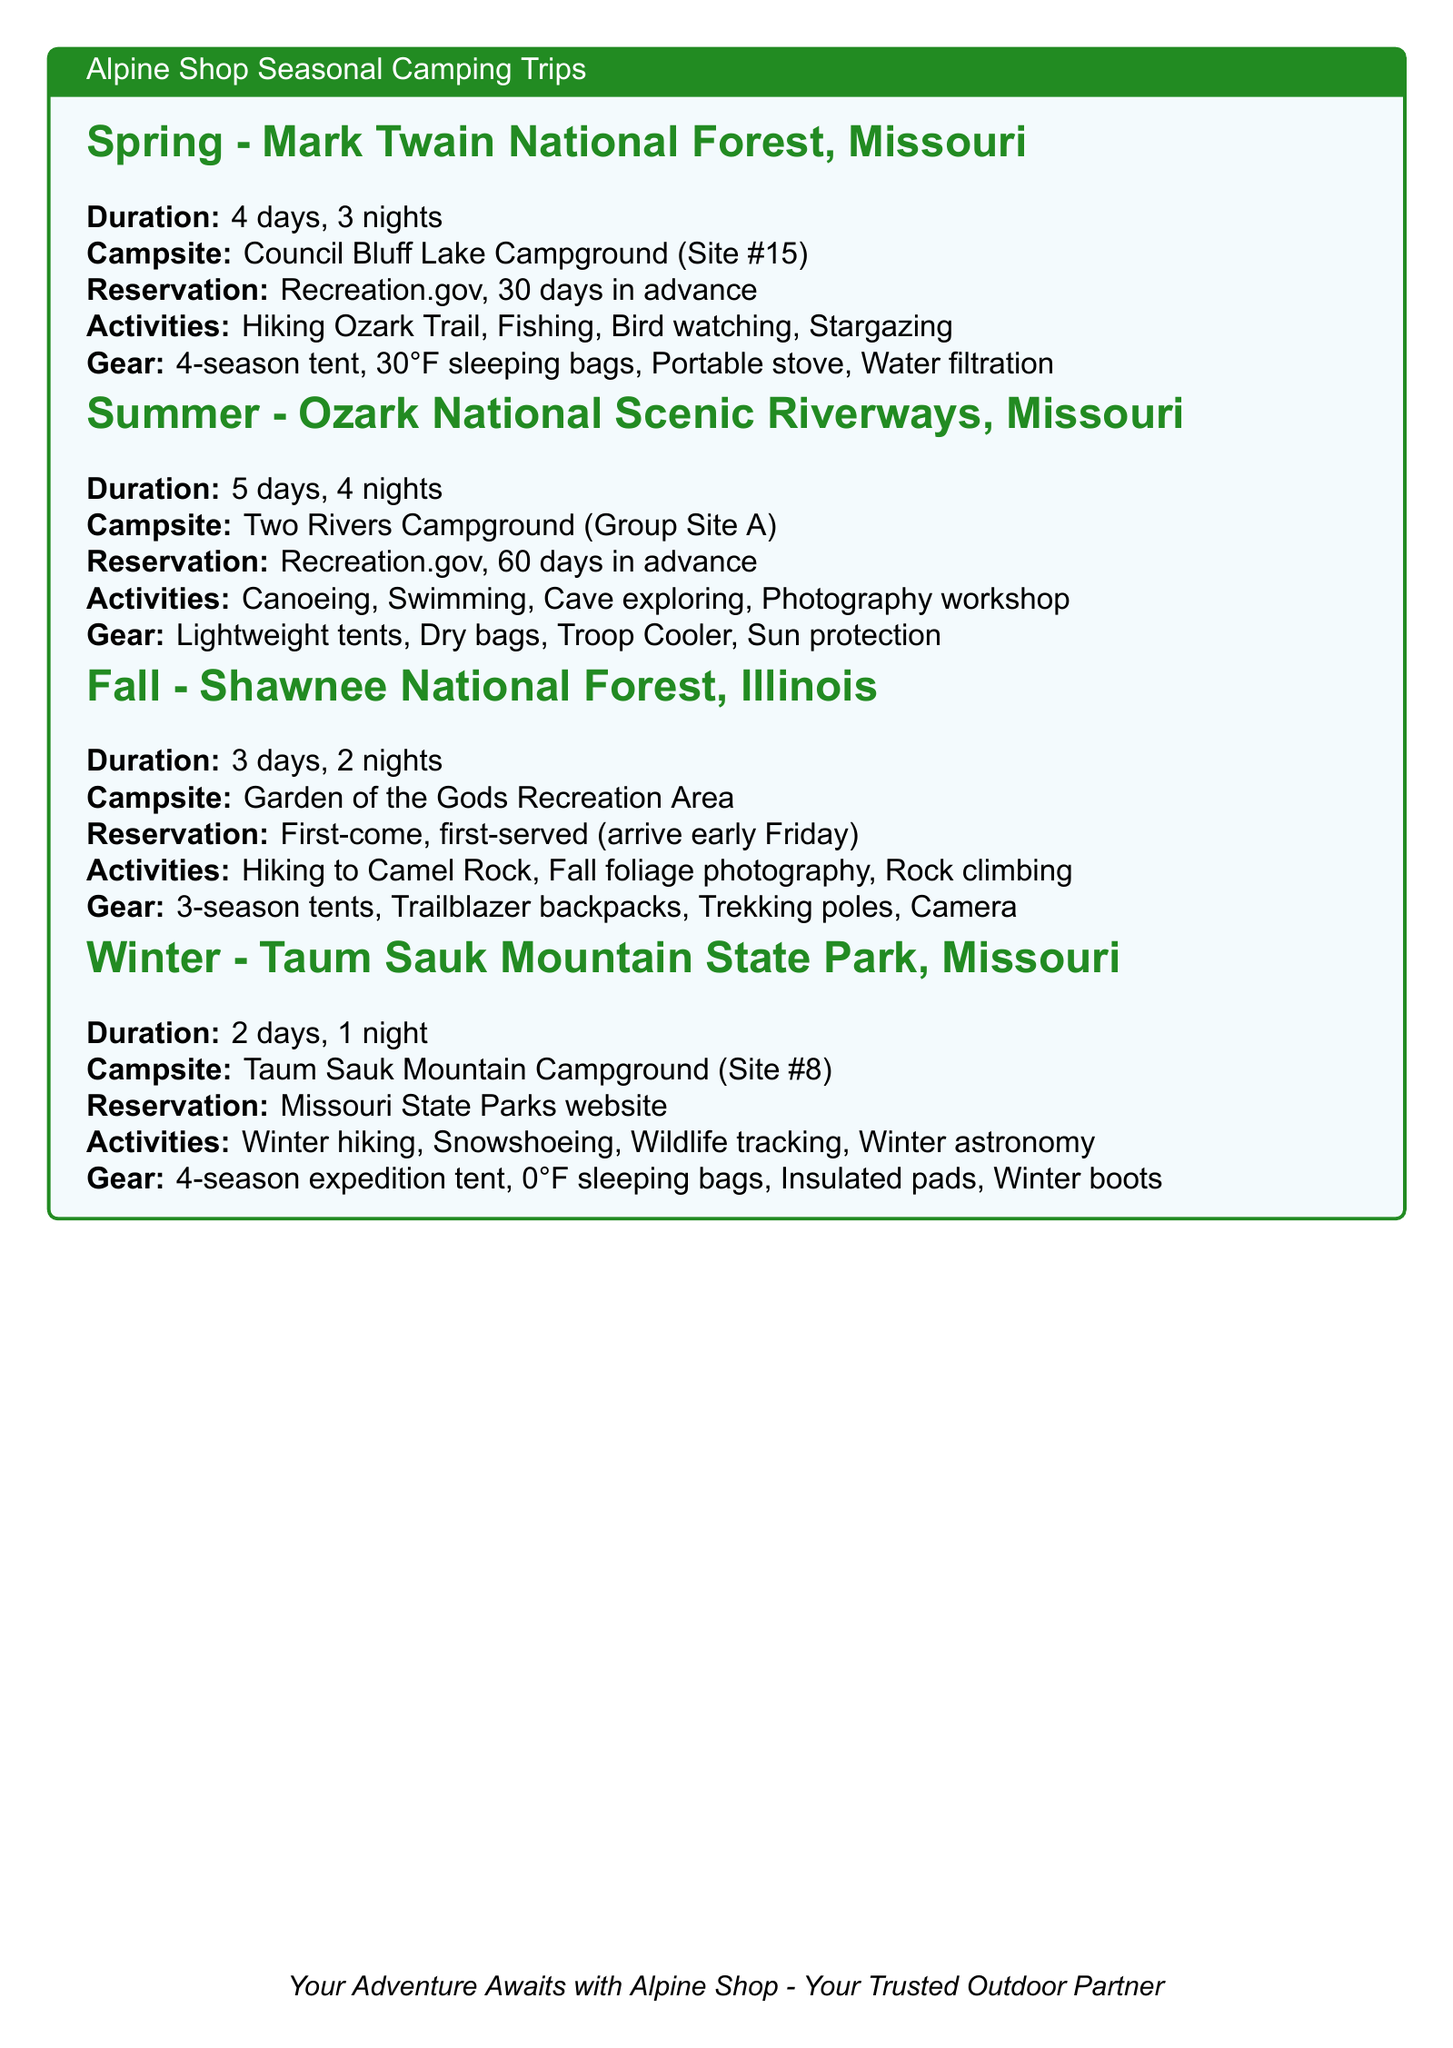What is the duration of the Spring trip? The duration of the Spring trip is stated in the document as 4 days, 3 nights.
Answer: 4 days, 3 nights Where is the Summer campsite located? The document specifies the location of the Summer campsite, which is Two Rivers Campground.
Answer: Two Rivers Campground What is the reservation notice for the Fall trip? The Fall trip specifies that reservations are first-come, first-served, and suggests arriving early on Friday.
Answer: First-come, first-served basis, arrive early on Friday How many group activities are listed for the Winter trip? By counting the group activities mentioned in the Winter section, there are four activities listed.
Answer: 4 What is one meal plan item for day 2 of the Spring trip? The meal plan for day 2 of the Spring trip includes Dutch oven chili and cornbread for dinner.
Answer: Dutch oven chili and cornbread What type of tent is suggested for the Summer camping trip? The Summer camping trip recommends using lightweight tents.
Answer: Lightweight tents Which activity is suggested for group activity in Fall? Among the group activities listed for Fall, one mentioned is rock climbing with an Alpine Shop guide.
Answer: Rock climbing with Alpine Shop guide What is the campsite info for the Winter trip? It states the winter campsite as Taum Sauk Mountain Campground (Site #8).
Answer: Taum Sauk Mountain Campground (Site #8) What is the recommended breakfast for day 1 of the Summer trip? The document lists bagels with cream cheese as the breakfast for day 1 of the Summer trip.
Answer: Bagels with cream cheese 